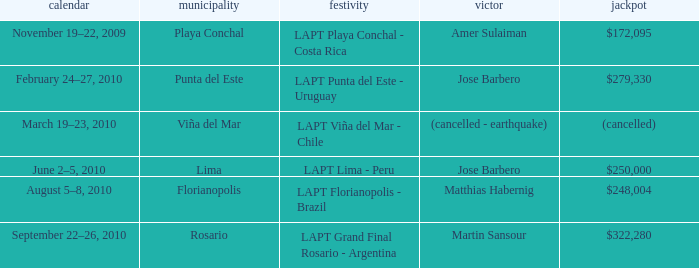What event has a $248,004 prize? LAPT Florianopolis - Brazil. 